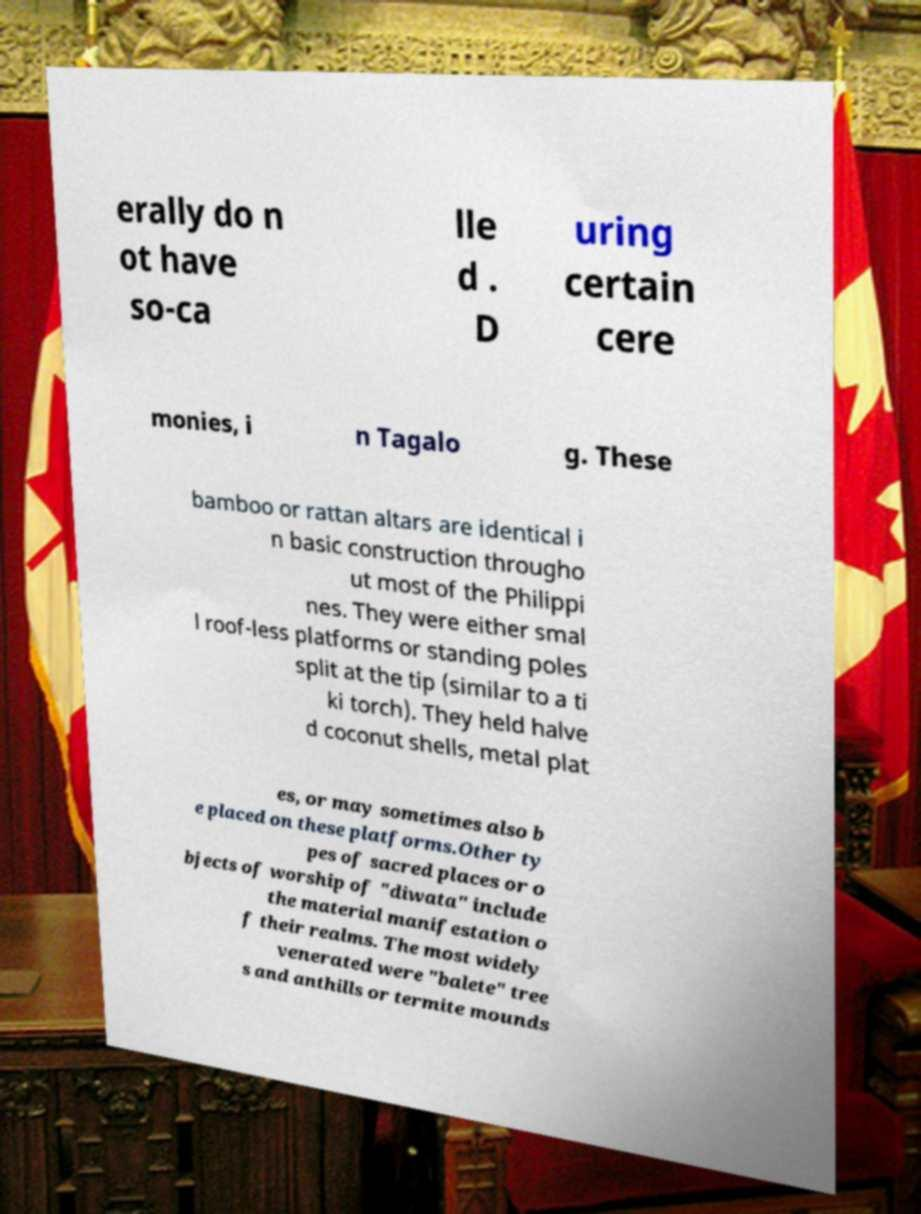Can you accurately transcribe the text from the provided image for me? erally do n ot have so-ca lle d . D uring certain cere monies, i n Tagalo g. These bamboo or rattan altars are identical i n basic construction througho ut most of the Philippi nes. They were either smal l roof-less platforms or standing poles split at the tip (similar to a ti ki torch). They held halve d coconut shells, metal plat es, or may sometimes also b e placed on these platforms.Other ty pes of sacred places or o bjects of worship of "diwata" include the material manifestation o f their realms. The most widely venerated were "balete" tree s and anthills or termite mounds 